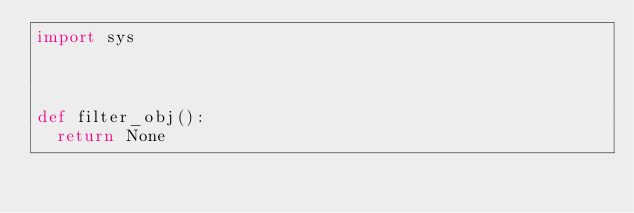<code> <loc_0><loc_0><loc_500><loc_500><_Python_>import sys



def filter_obj():
  return None
</code> 